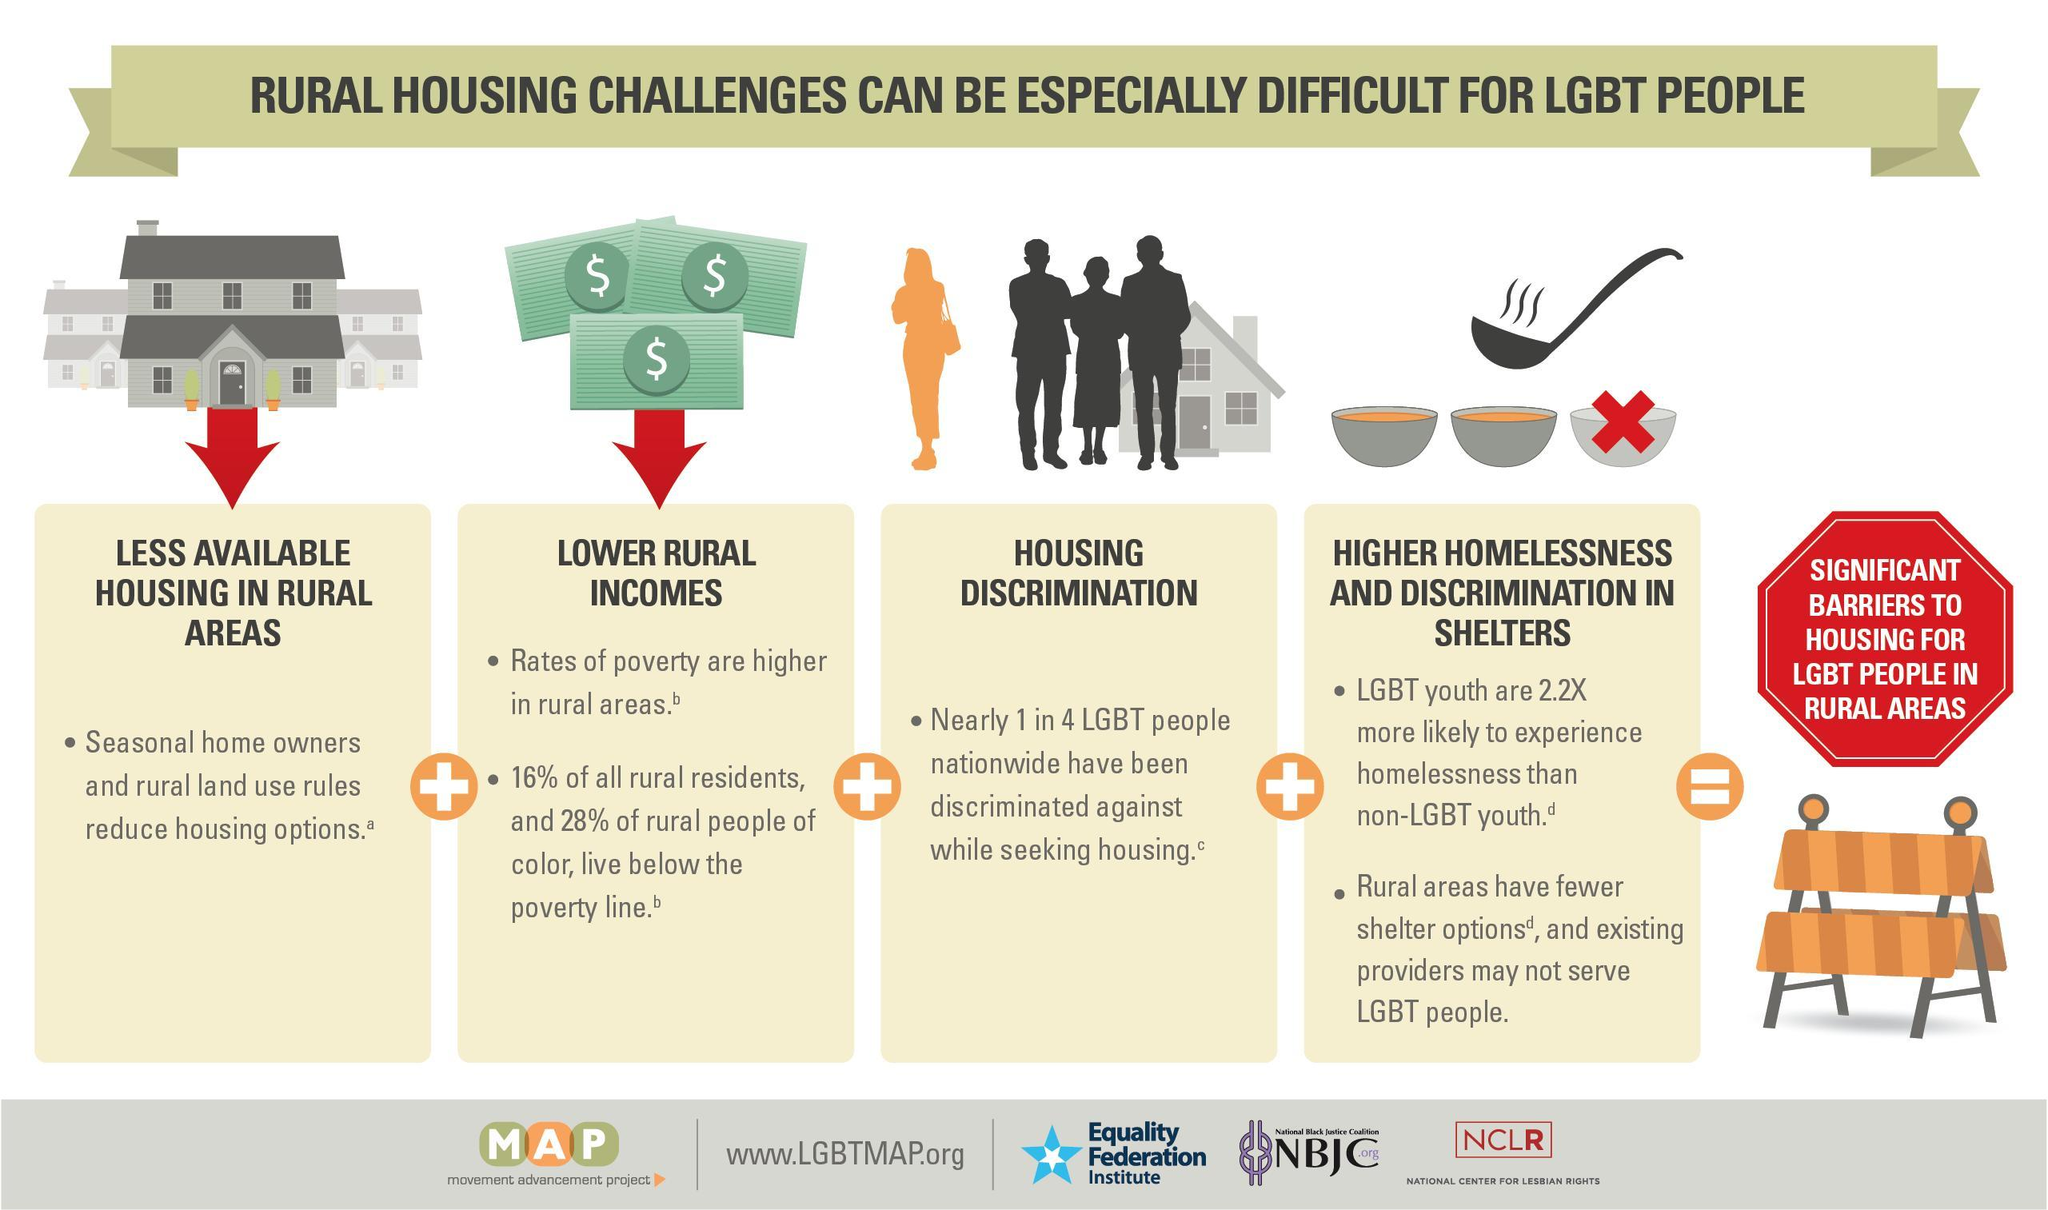How many rural housing challenges are there?
Answer the question with a short phrase. 4 